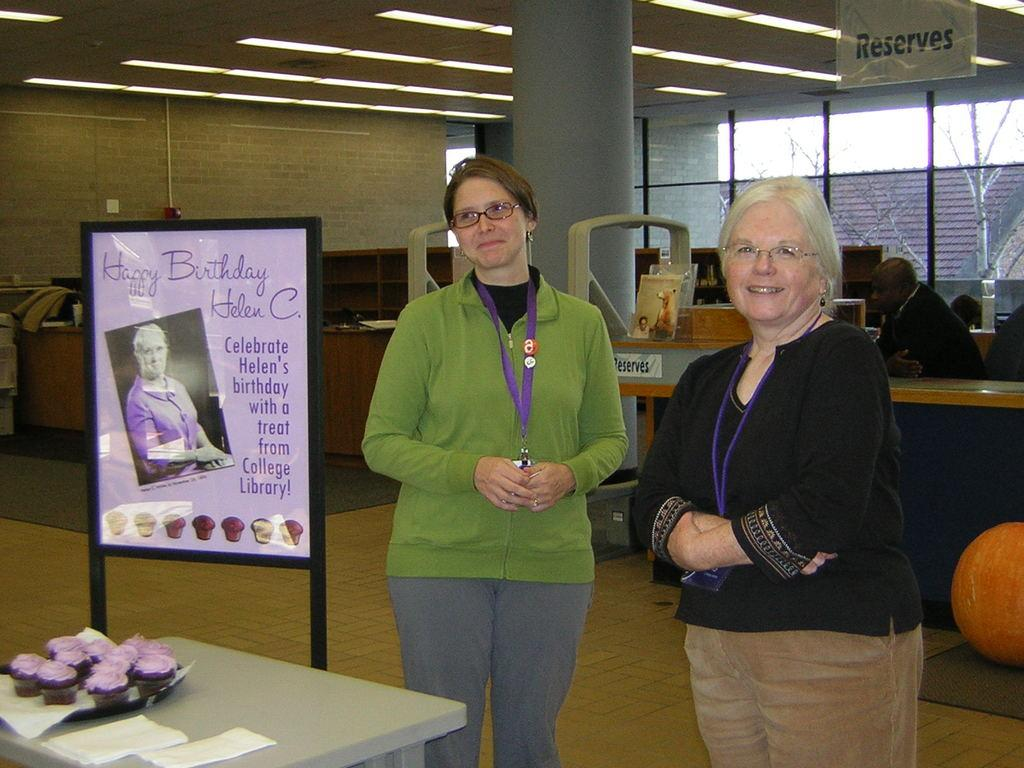How many people are in the image? There are three people in the image. Can you describe the two people in the front? Two women are standing in front. What is present on the table in the image? There are cupcakes on the table. What other object can be seen in the image besides the table? There is a board in the image. Can you see a hill in the background of the image? There is no hill visible in the background of the image. Are the two women in the front kissing in the image? There is no indication of a kiss between the two women in the image. 